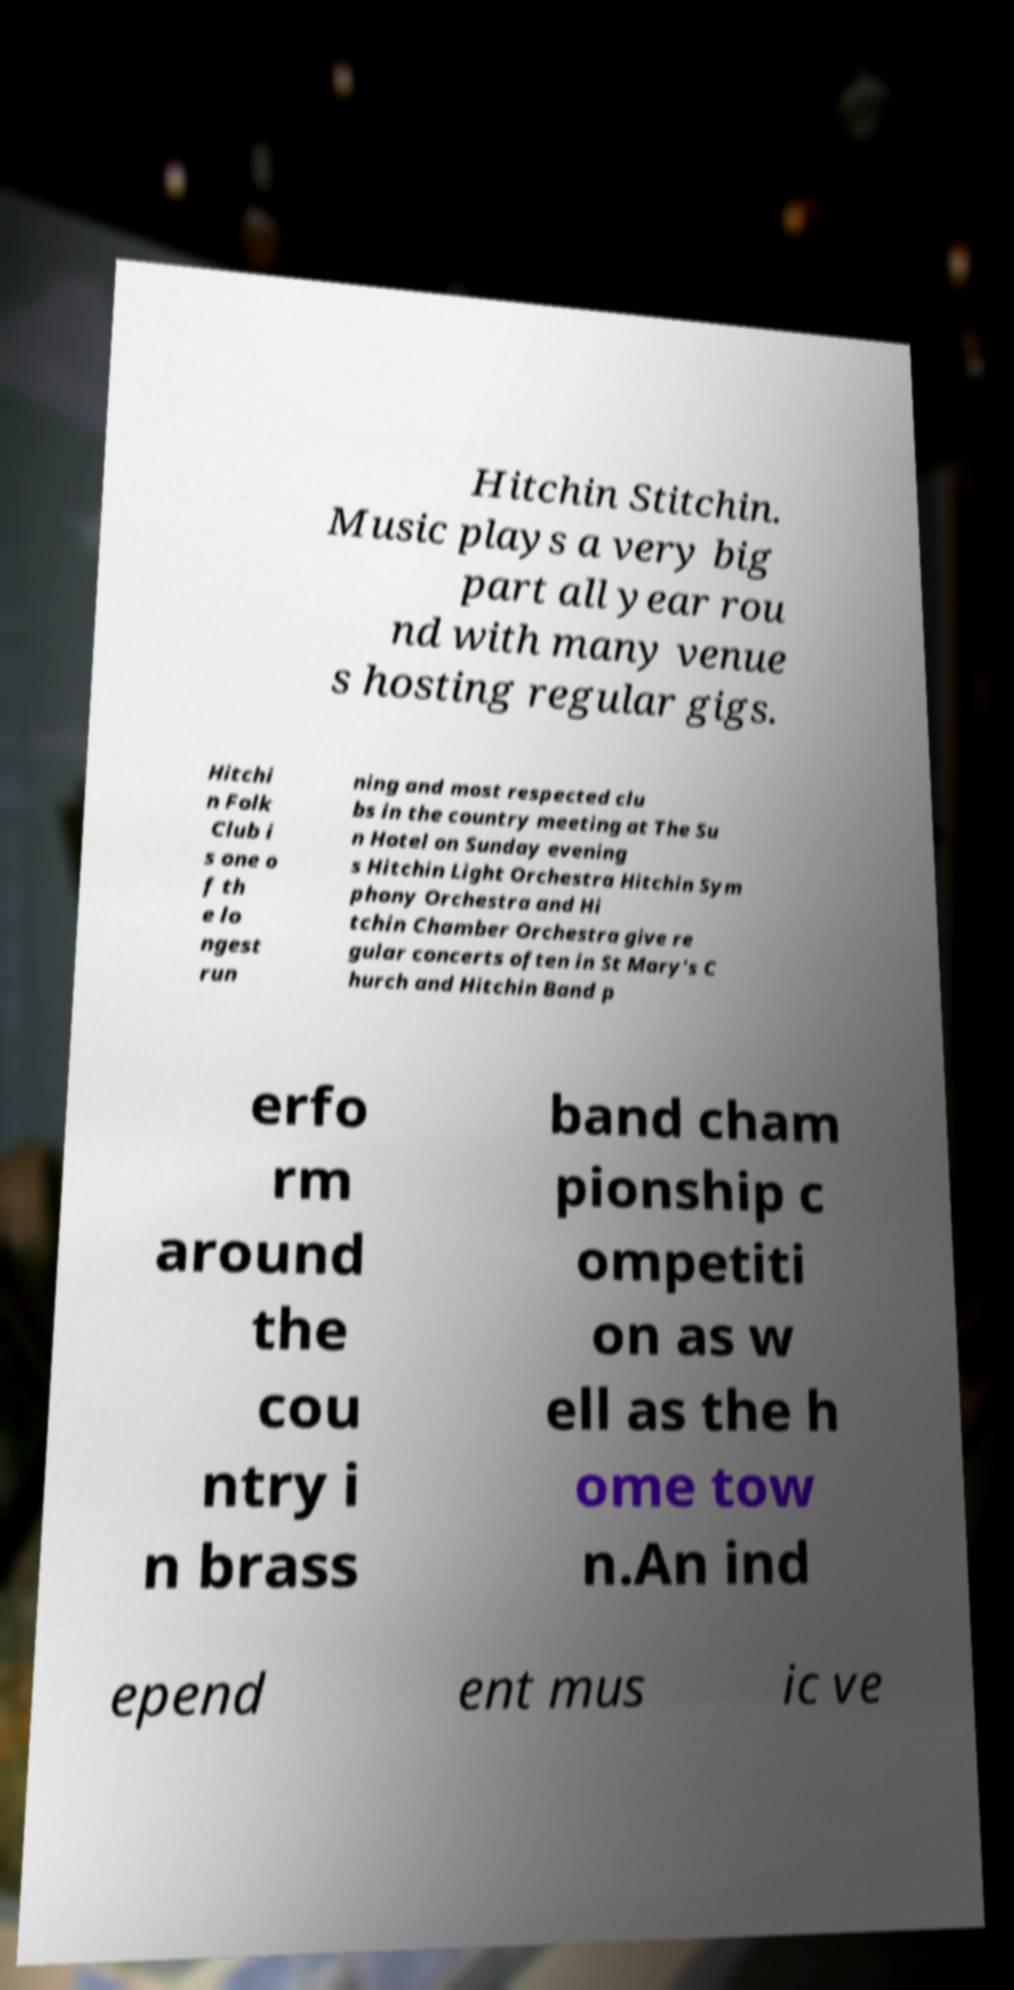Please read and relay the text visible in this image. What does it say? Hitchin Stitchin. Music plays a very big part all year rou nd with many venue s hosting regular gigs. Hitchi n Folk Club i s one o f th e lo ngest run ning and most respected clu bs in the country meeting at The Su n Hotel on Sunday evening s Hitchin Light Orchestra Hitchin Sym phony Orchestra and Hi tchin Chamber Orchestra give re gular concerts often in St Mary's C hurch and Hitchin Band p erfo rm around the cou ntry i n brass band cham pionship c ompetiti on as w ell as the h ome tow n.An ind epend ent mus ic ve 